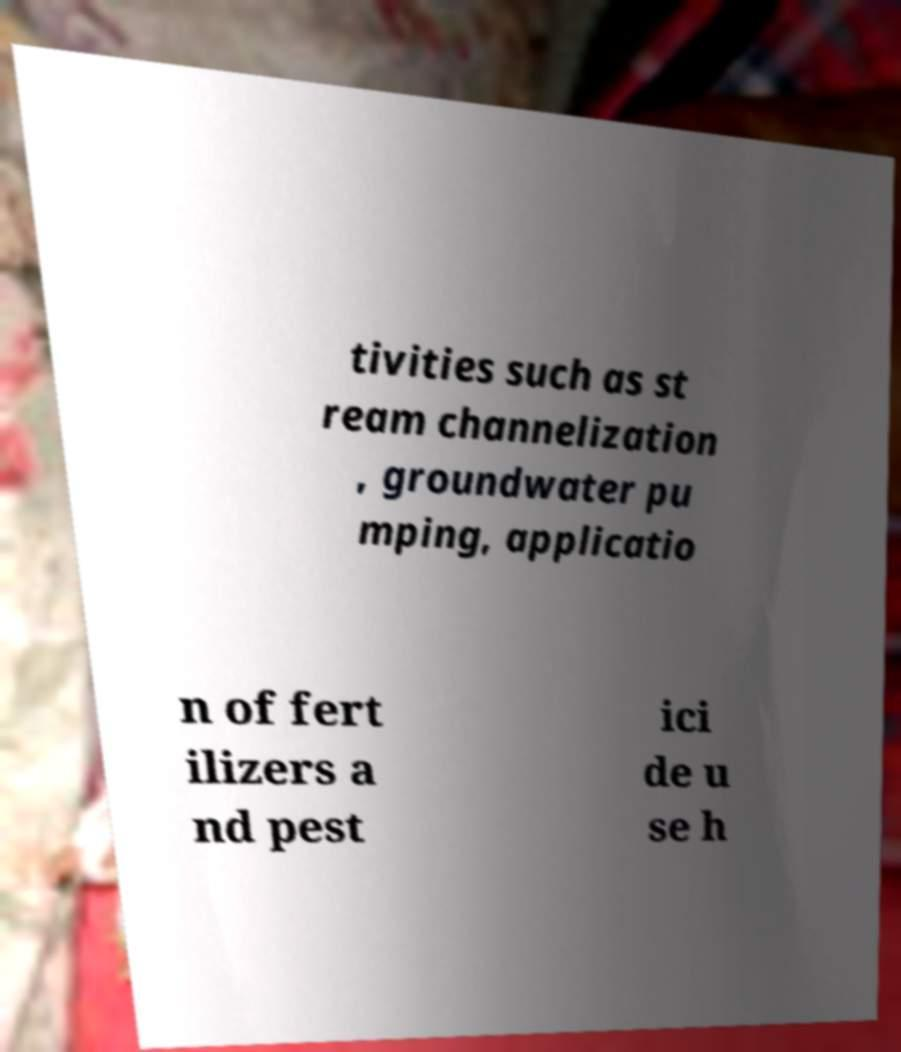Could you assist in decoding the text presented in this image and type it out clearly? tivities such as st ream channelization , groundwater pu mping, applicatio n of fert ilizers a nd pest ici de u se h 